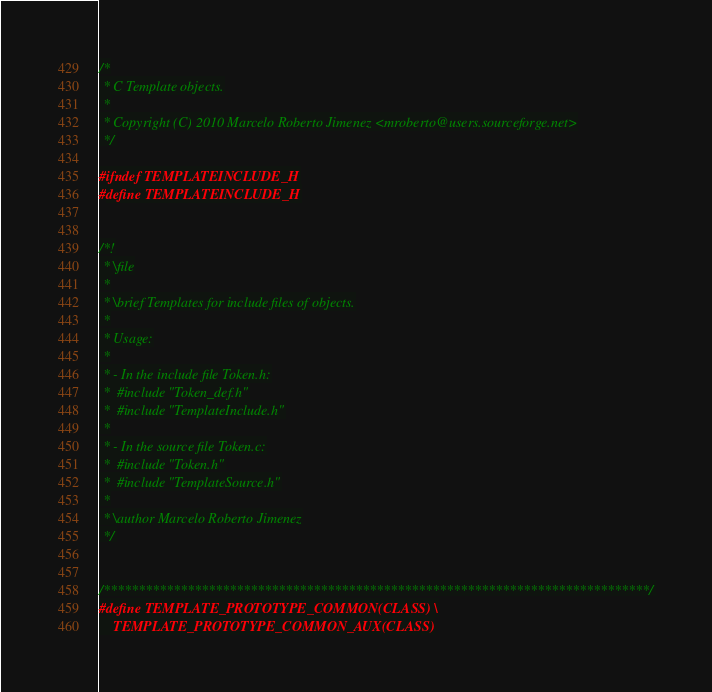<code> <loc_0><loc_0><loc_500><loc_500><_C_>/*
 * C Template objects.
 *
 * Copyright (C) 2010 Marcelo Roberto Jimenez <mroberto@users.sourceforge.net>
 */

#ifndef TEMPLATEINCLUDE_H
#define TEMPLATEINCLUDE_H


/*!
 * \file
 *
 * \brief Templates for include files of objects.
 *
 * Usage:
 *
 * - In the include file Token.h:
 *	#include "Token_def.h"
 *	#include "TemplateInclude.h"
 *
 * - In the source file Token.c:
 *	#include "Token.h"
 *	#include "TemplateSource.h"
 *
 * \author Marcelo Roberto Jimenez
 */


/******************************************************************************/
#define TEMPLATE_PROTOTYPE_COMMON(CLASS) \
	TEMPLATE_PROTOTYPE_COMMON_AUX(CLASS)</code> 